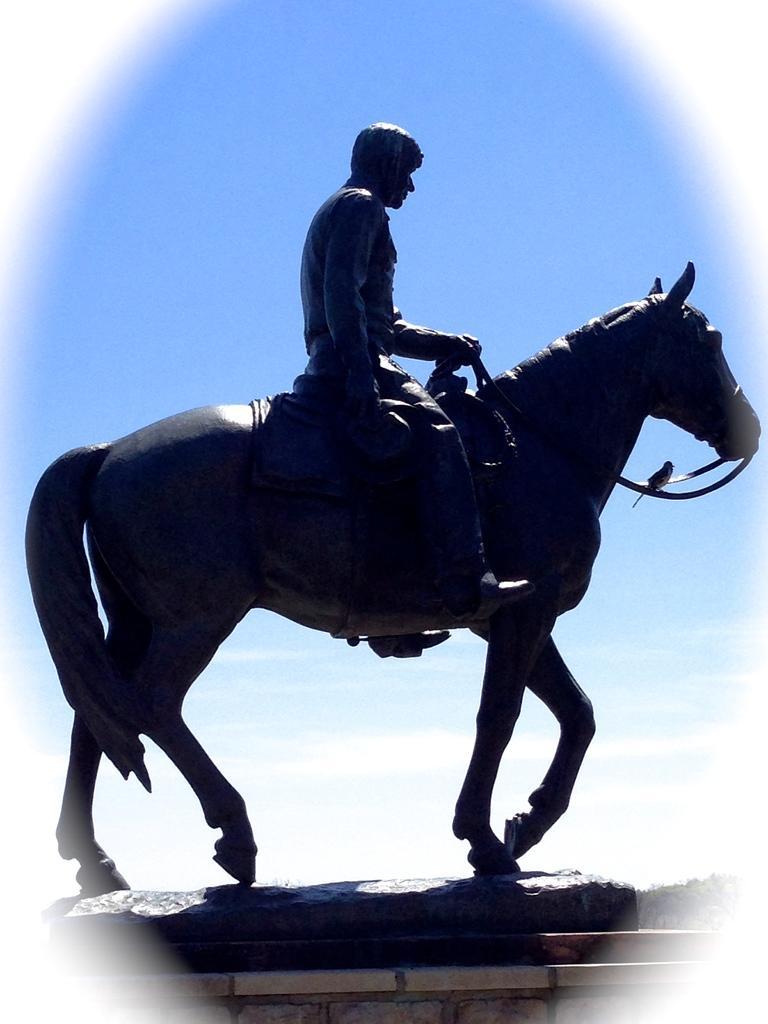In one or two sentences, can you explain what this image depicts? In the image there is a statue of a horse and a man is sitting on it. Behind the statue there is a sky in the background. 